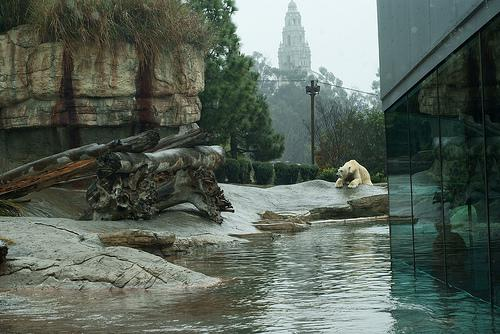Question: when was the photo taken?
Choices:
A. At dawn.
B. Daytime.
C. At dusk.
D. In the morning.
Answer with the letter. Answer: B Question: what animal is shown?
Choices:
A. Duck.
B. Dog.
C. Polar bear.
D. Cat.
Answer with the letter. Answer: C Question: where was the photo taken?
Choices:
A. Zoo.
B. Preserve.
C. Safari.
D. At the park.
Answer with the letter. Answer: A Question: what is the wall on the bottom right made of?
Choices:
A. Glass.
B. Concrete.
C. Brick.
D. Metal.
Answer with the letter. Answer: A Question: what is in the background?
Choices:
A. Tree.
B. Prison.
C. Bridge.
D. Tower.
Answer with the letter. Answer: D Question: how many animals are shown?
Choices:
A. Two.
B. One.
C. Four.
D. A dozen.
Answer with the letter. Answer: B Question: how many of the bear's paws are shown?
Choices:
A. Three.
B. One.
C. Two.
D. Four.
Answer with the letter. Answer: C 